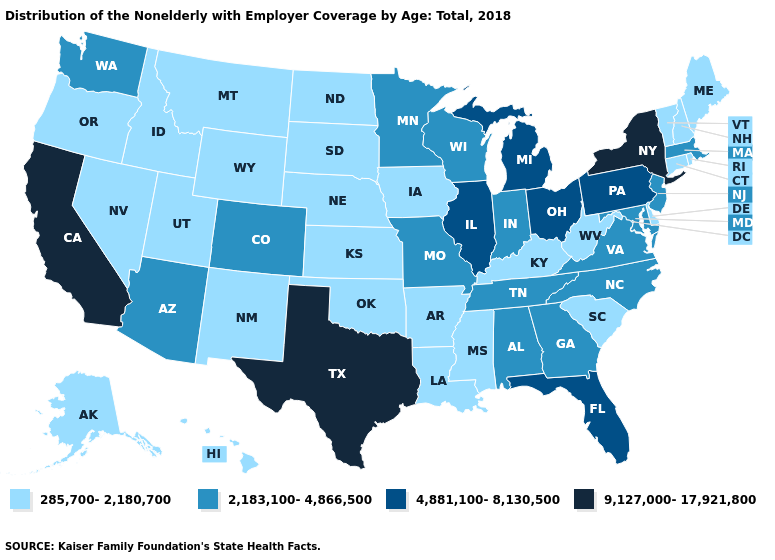Name the states that have a value in the range 9,127,000-17,921,800?
Be succinct. California, New York, Texas. What is the value of South Dakota?
Quick response, please. 285,700-2,180,700. Does the first symbol in the legend represent the smallest category?
Be succinct. Yes. Name the states that have a value in the range 2,183,100-4,866,500?
Write a very short answer. Alabama, Arizona, Colorado, Georgia, Indiana, Maryland, Massachusetts, Minnesota, Missouri, New Jersey, North Carolina, Tennessee, Virginia, Washington, Wisconsin. Does Delaware have the lowest value in the South?
Give a very brief answer. Yes. Does the first symbol in the legend represent the smallest category?
Answer briefly. Yes. Does Texas have the highest value in the USA?
Concise answer only. Yes. Is the legend a continuous bar?
Answer briefly. No. Name the states that have a value in the range 285,700-2,180,700?
Keep it brief. Alaska, Arkansas, Connecticut, Delaware, Hawaii, Idaho, Iowa, Kansas, Kentucky, Louisiana, Maine, Mississippi, Montana, Nebraska, Nevada, New Hampshire, New Mexico, North Dakota, Oklahoma, Oregon, Rhode Island, South Carolina, South Dakota, Utah, Vermont, West Virginia, Wyoming. Does South Carolina have a lower value than Alabama?
Short answer required. Yes. Name the states that have a value in the range 9,127,000-17,921,800?
Quick response, please. California, New York, Texas. Does Nebraska have a lower value than New York?
Short answer required. Yes. Does Colorado have the same value as Kansas?
Answer briefly. No. 